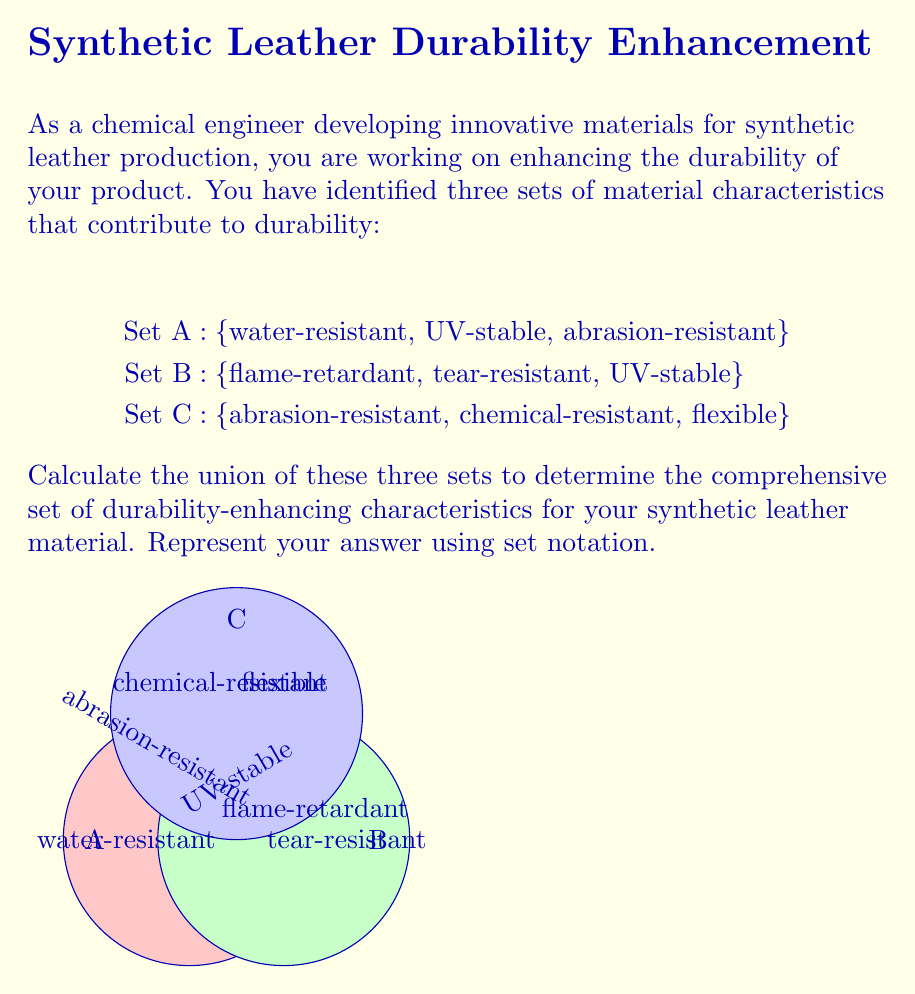Solve this math problem. To solve this problem, we need to find the union of sets A, B, and C. The union of sets includes all unique elements from all sets without repetition. Let's approach this step-by-step:

1. First, let's list out all the elements in each set:
   Set A: {water-resistant, UV-stable, abrasion-resistant}
   Set B: {flame-retardant, tear-resistant, UV-stable}
   Set C: {abrasion-resistant, chemical-resistant, flexible}

2. Now, let's combine all these elements, noting any repetitions:
   - water-resistant (from A)
   - UV-stable (from A and B, count only once)
   - abrasion-resistant (from A and C, count only once)
   - flame-retardant (from B)
   - tear-resistant (from B)
   - chemical-resistant (from C)
   - flexible (from C)

3. The union operation in set theory is denoted by the symbol $\cup$. So, we can express the union of these sets as:

   $A \cup B \cup C$

4. Writing out the full set of unique elements:

   $A \cup B \cup C = \text{\{water-resistant, UV-stable, abrasion-resistant, flame-retardant, tear-resistant, chemical-resistant, flexible\}}$

This union represents the comprehensive set of durability-enhancing characteristics for the synthetic leather material, combining all unique properties from the three original sets.
Answer: $A \cup B \cup C = \text{\{water-resistant, UV-stable, abrasion-resistant, flame-retardant, tear-resistant, chemical-resistant, flexible\}}$ 